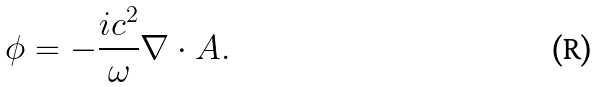<formula> <loc_0><loc_0><loc_500><loc_500>\phi = - \frac { i c ^ { 2 } } { \omega } \nabla \cdot A .</formula> 